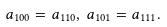<formula> <loc_0><loc_0><loc_500><loc_500>a _ { 1 0 0 } = a _ { 1 1 0 } , \, a _ { 1 0 1 } = a _ { 1 1 1 } .</formula> 